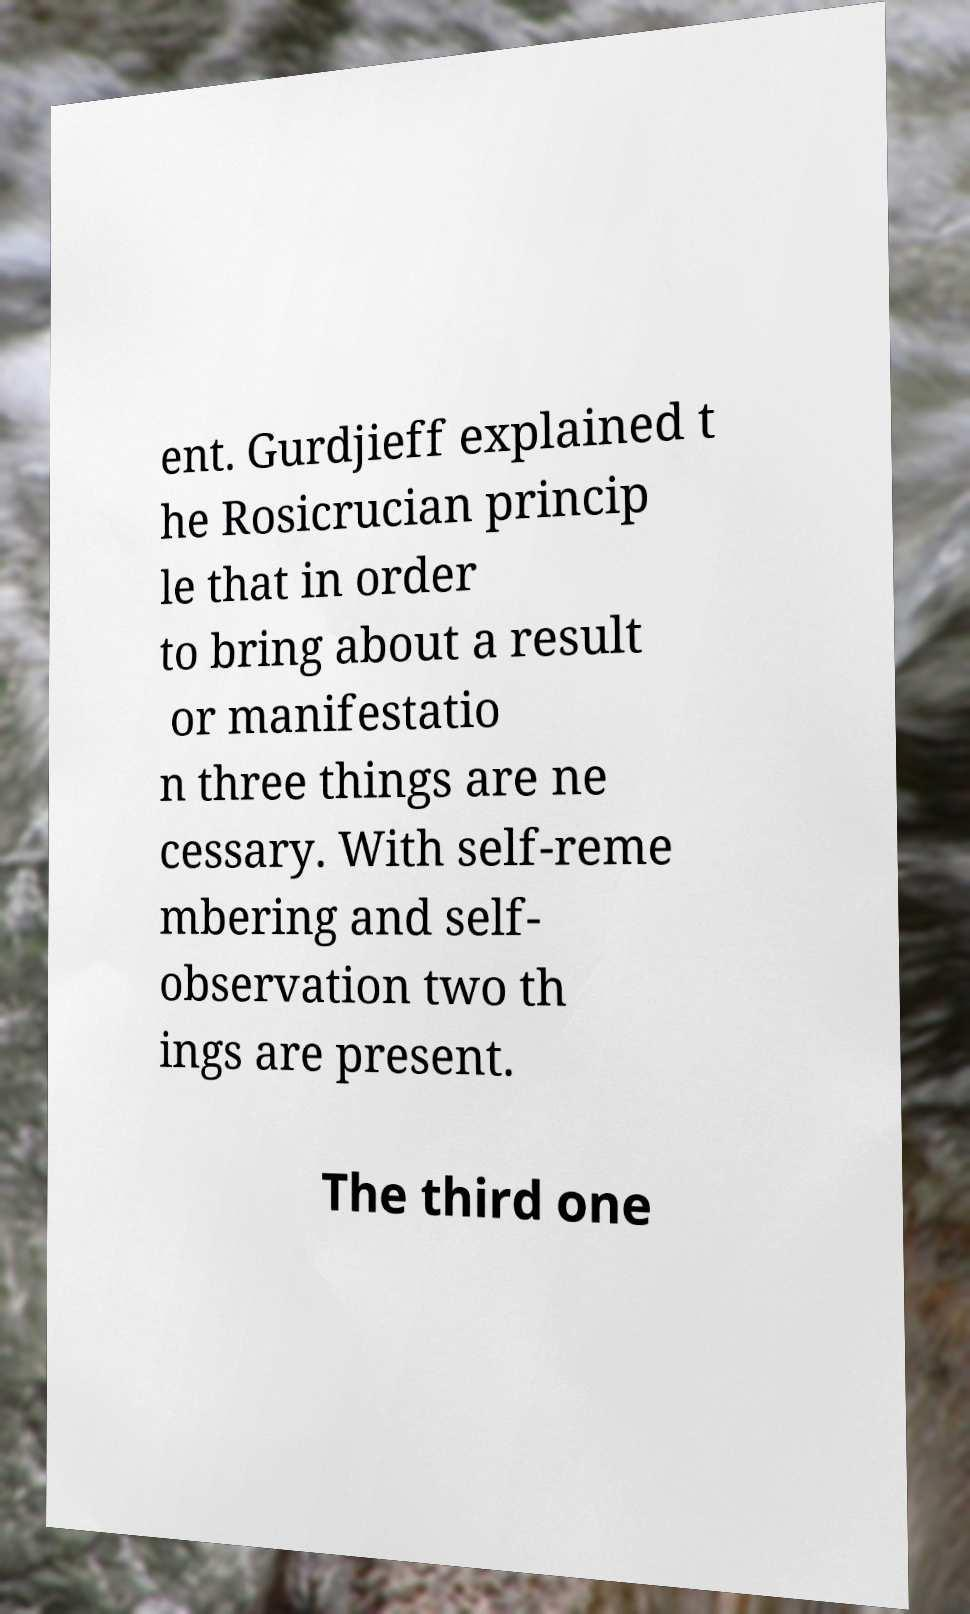Please read and relay the text visible in this image. What does it say? ent. Gurdjieff explained t he Rosicrucian princip le that in order to bring about a result or manifestatio n three things are ne cessary. With self-reme mbering and self- observation two th ings are present. The third one 